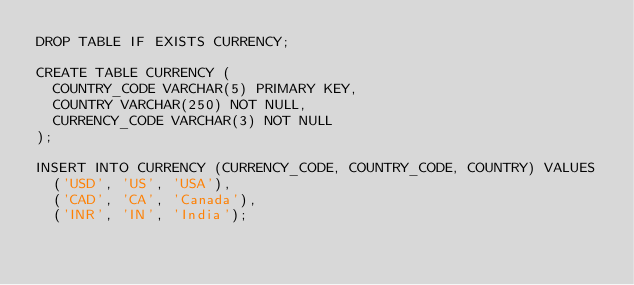Convert code to text. <code><loc_0><loc_0><loc_500><loc_500><_SQL_>DROP TABLE IF EXISTS CURRENCY;

CREATE TABLE CURRENCY (
  COUNTRY_CODE VARCHAR(5) PRIMARY KEY,
  COUNTRY VARCHAR(250) NOT NULL,
  CURRENCY_CODE VARCHAR(3) NOT NULL
);

INSERT INTO CURRENCY (CURRENCY_CODE, COUNTRY_CODE, COUNTRY) VALUES
  ('USD', 'US', 'USA'),
  ('CAD', 'CA', 'Canada'),
  ('INR', 'IN', 'India');</code> 